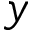Convert formula to latex. <formula><loc_0><loc_0><loc_500><loc_500>y</formula> 